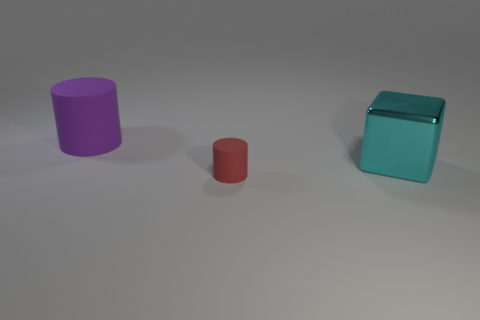Is there anything else that has the same size as the red thing?
Ensure brevity in your answer.  No. The big thing in front of the cylinder that is left of the rubber cylinder that is on the right side of the big purple rubber object is made of what material?
Your answer should be very brief. Metal. There is a matte object on the right side of the big cylinder; is its shape the same as the big matte thing left of the big cyan thing?
Keep it short and to the point. Yes. What number of other things are there of the same material as the cyan cube
Offer a terse response. 0. Is the material of the large object to the right of the red rubber thing the same as the large thing that is to the left of the small cylinder?
Make the answer very short. No. Is there anything else that has the same color as the small cylinder?
Offer a very short reply. No. What number of cylinders are there?
Keep it short and to the point. 2. There is a thing that is in front of the large cylinder and behind the tiny cylinder; what shape is it?
Make the answer very short. Cube. There is a rubber thing right of the cylinder to the left of the thing in front of the metal object; what is its shape?
Offer a terse response. Cylinder. What is the object that is behind the small red matte cylinder and to the left of the large cyan shiny cube made of?
Make the answer very short. Rubber. 